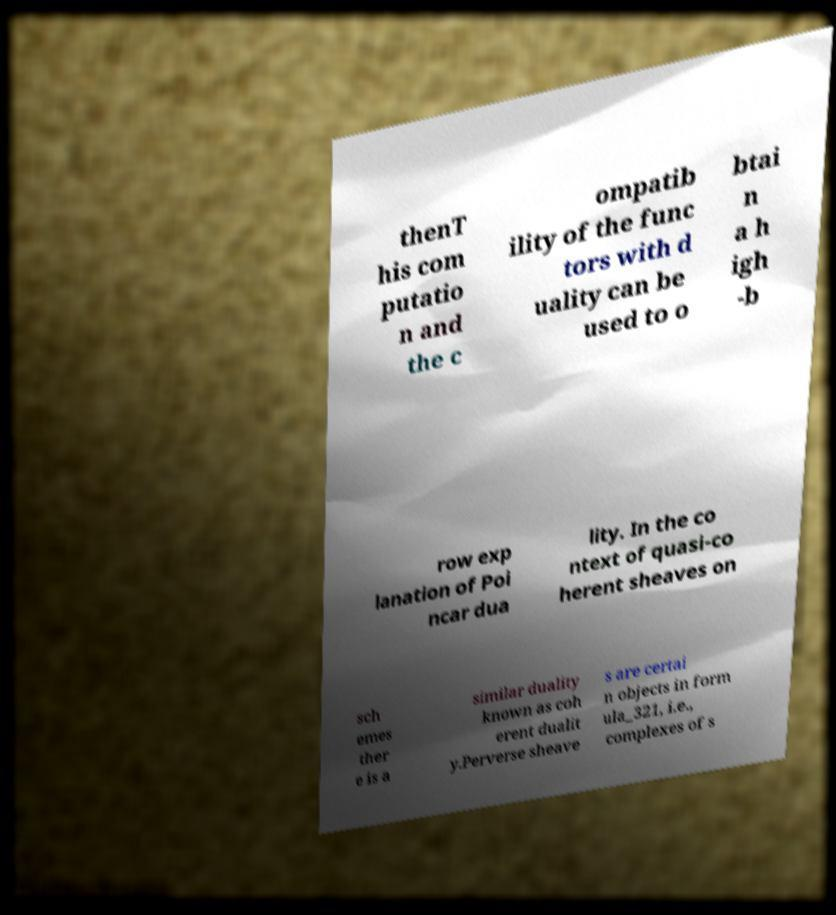Can you accurately transcribe the text from the provided image for me? thenT his com putatio n and the c ompatib ility of the func tors with d uality can be used to o btai n a h igh -b row exp lanation of Poi ncar dua lity. In the co ntext of quasi-co herent sheaves on sch emes ther e is a similar duality known as coh erent dualit y.Perverse sheave s are certai n objects in form ula_321, i.e., complexes of s 